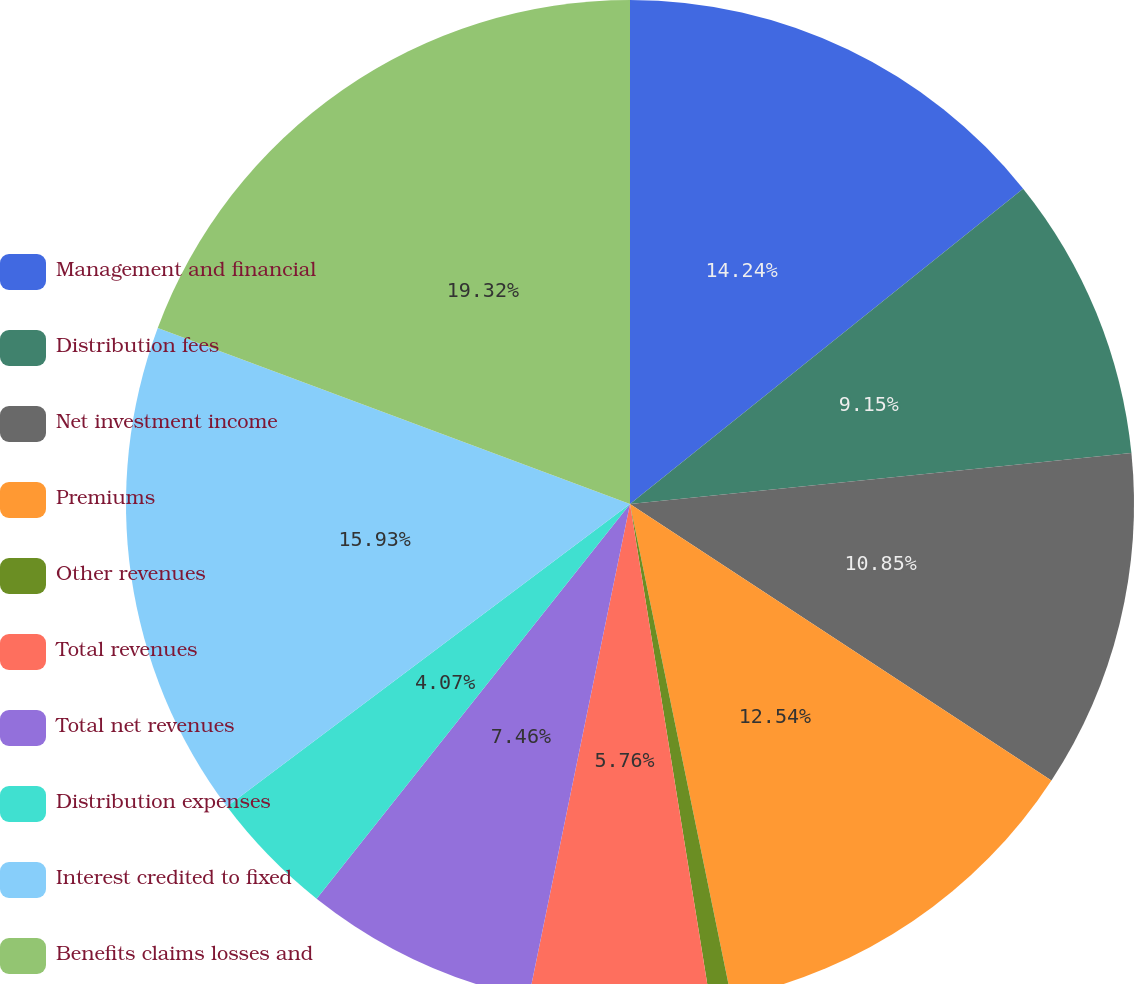Convert chart. <chart><loc_0><loc_0><loc_500><loc_500><pie_chart><fcel>Management and financial<fcel>Distribution fees<fcel>Net investment income<fcel>Premiums<fcel>Other revenues<fcel>Total revenues<fcel>Total net revenues<fcel>Distribution expenses<fcel>Interest credited to fixed<fcel>Benefits claims losses and<nl><fcel>14.24%<fcel>9.15%<fcel>10.85%<fcel>12.54%<fcel>0.68%<fcel>5.76%<fcel>7.46%<fcel>4.07%<fcel>15.93%<fcel>19.32%<nl></chart> 